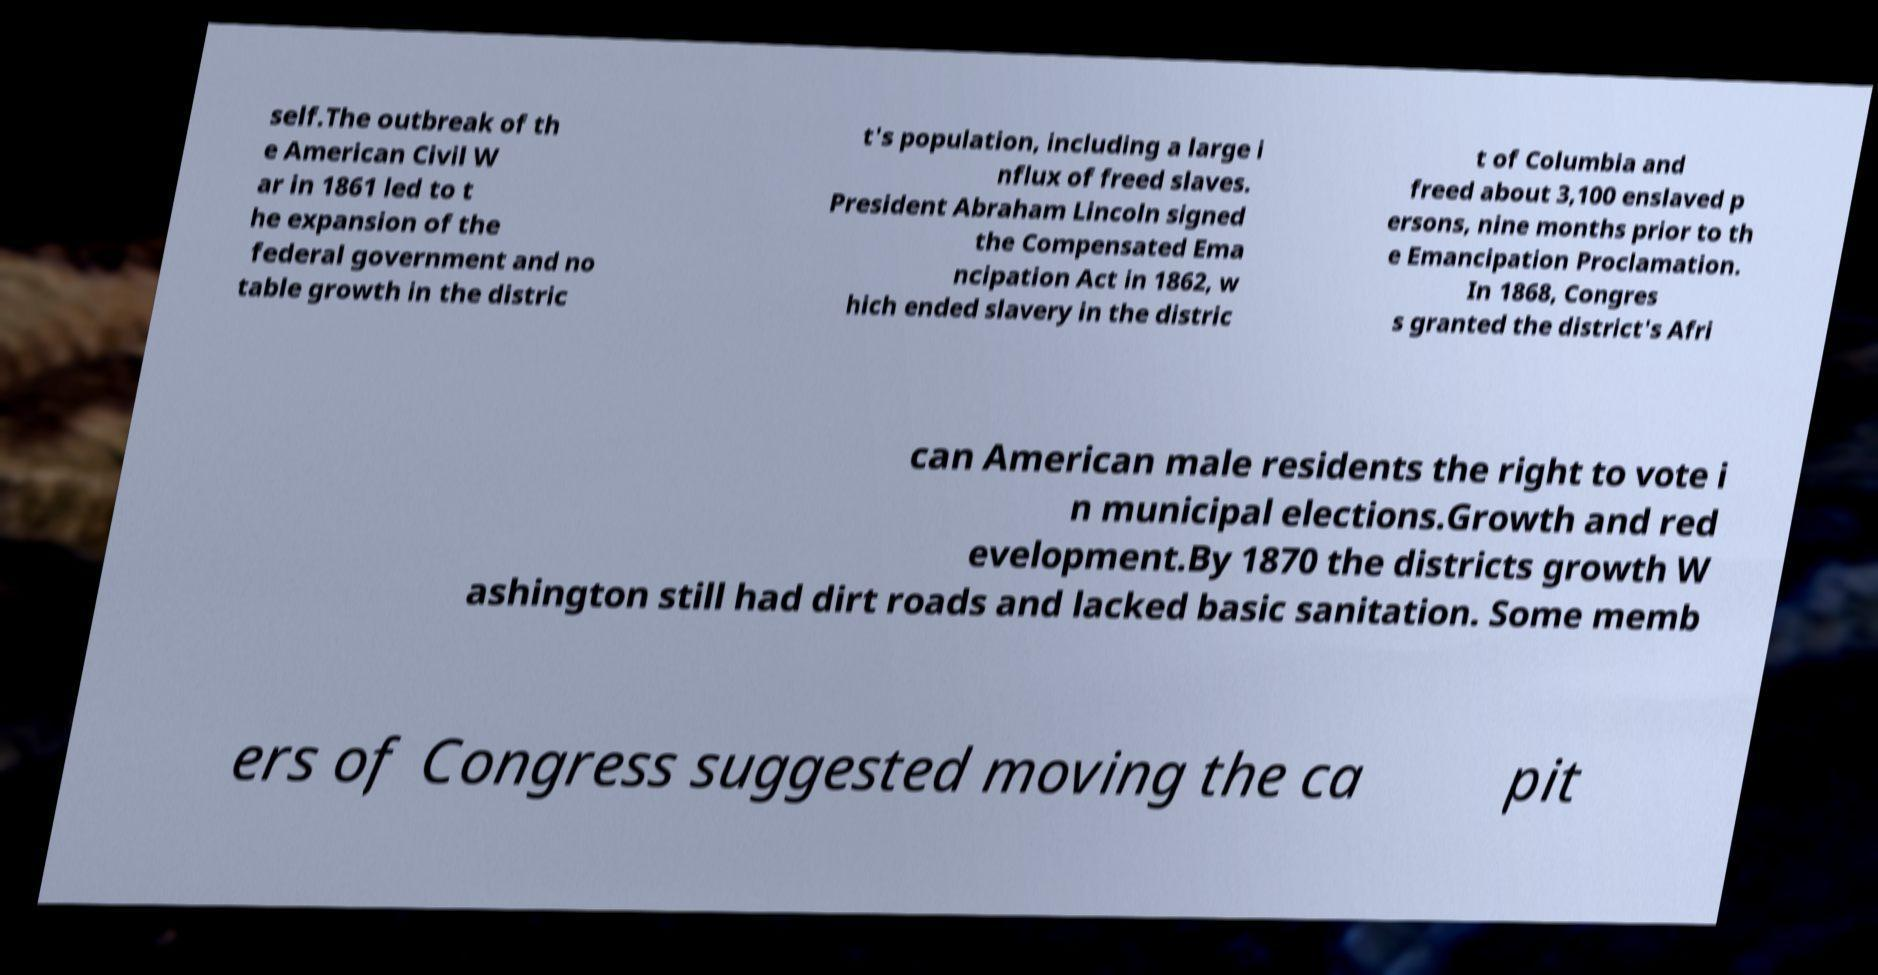Could you assist in decoding the text presented in this image and type it out clearly? self.The outbreak of th e American Civil W ar in 1861 led to t he expansion of the federal government and no table growth in the distric t's population, including a large i nflux of freed slaves. President Abraham Lincoln signed the Compensated Ema ncipation Act in 1862, w hich ended slavery in the distric t of Columbia and freed about 3,100 enslaved p ersons, nine months prior to th e Emancipation Proclamation. In 1868, Congres s granted the district's Afri can American male residents the right to vote i n municipal elections.Growth and red evelopment.By 1870 the districts growth W ashington still had dirt roads and lacked basic sanitation. Some memb ers of Congress suggested moving the ca pit 